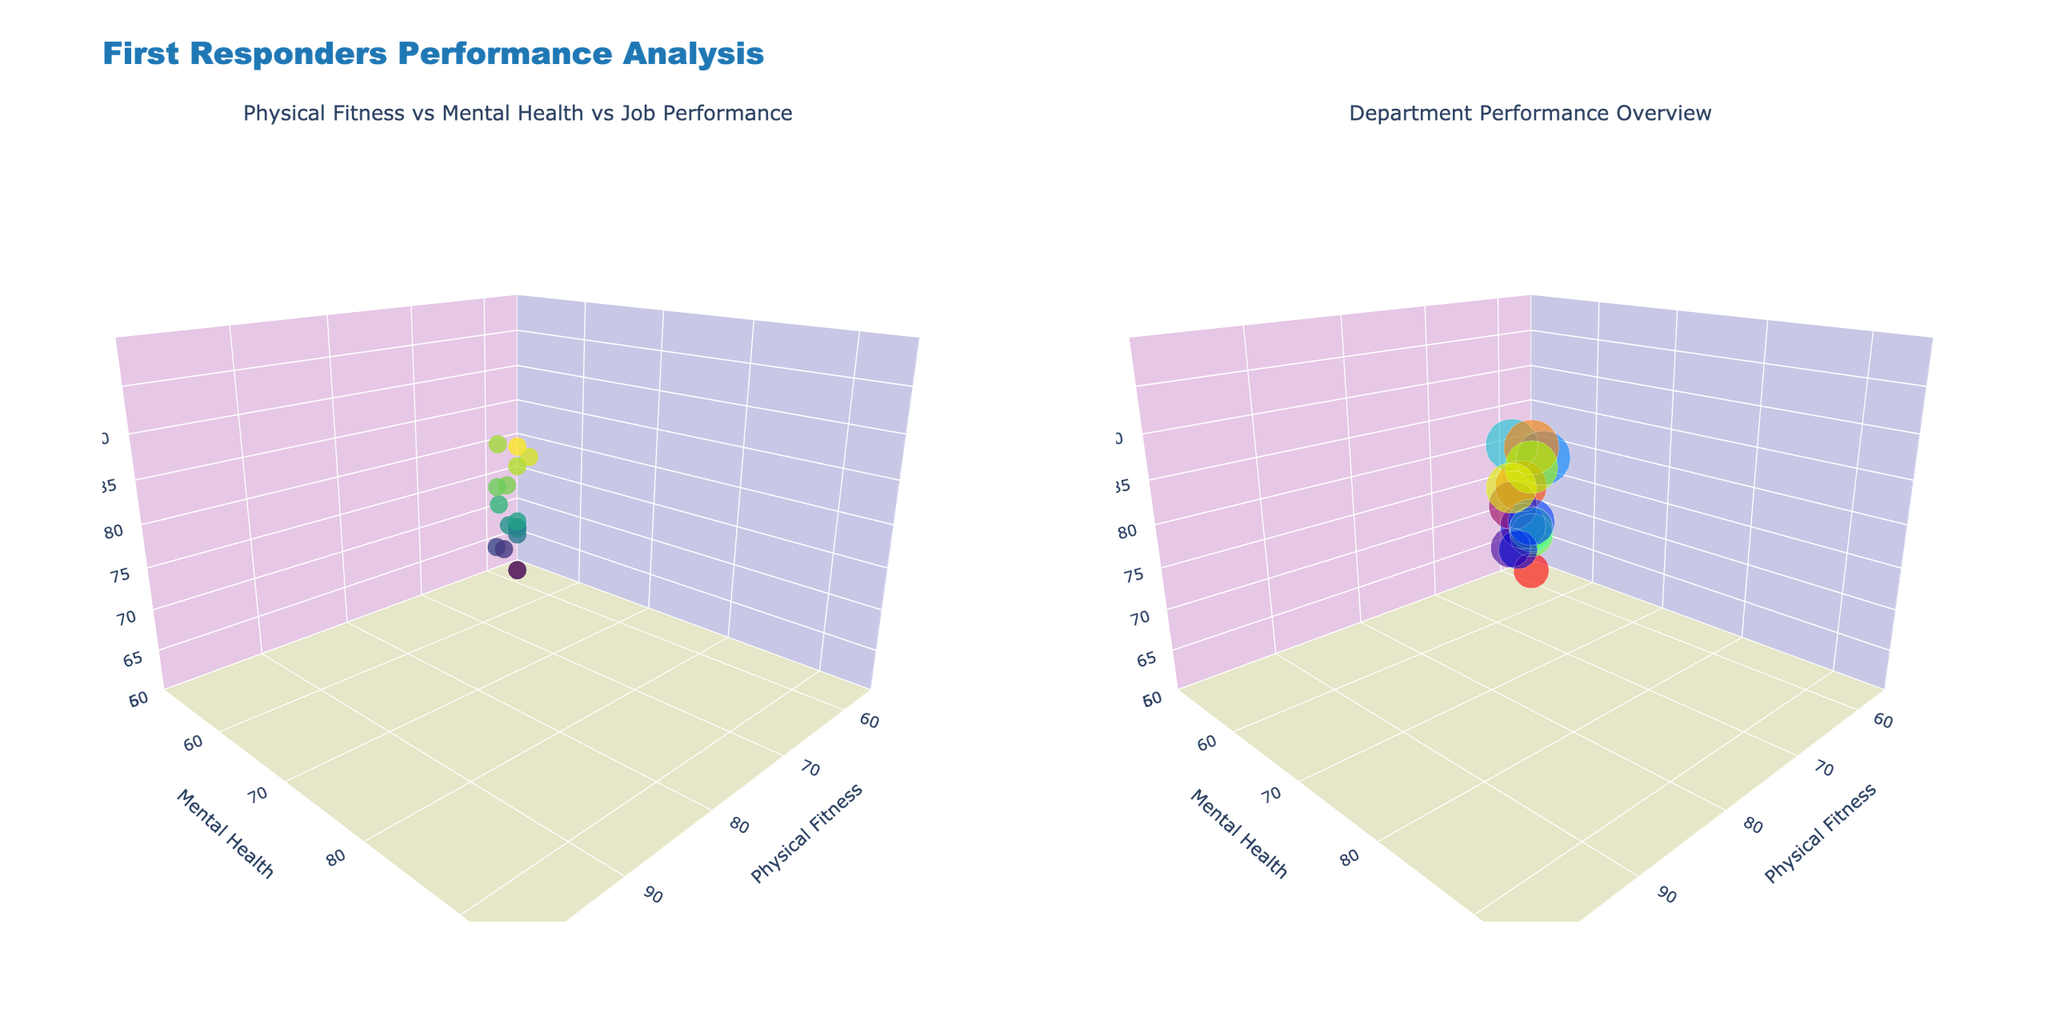what does the title of the figure say? The title of the figure displayed at the top of the plot provides an overall description of the data being visualized. It is "First Responders Performance Analysis".
Answer: First Responders Performance Analysis what are the axis titles for the scatter plot on the left? The axis titles for the scatter plot on the left describe what each axis represents. They are "Physical Fitness" for the x-axis, "Mental Health" for the y-axis, and "Job Performance" for the z-axis.
Answer: Physical Fitness, Mental Health, Job Performance how many data points appear in the scatter plot on the left? There is one marker for each data point in the scatter plot. Counting these markers gives the total number of data points, which is 15.
Answer: 15 which department has the highest job performance? To determine which department has the highest job performance, look for the data point that is highest along the z-axis. The SWAT Team in Boston has the highest job performance at 97.
Answer: SWAT Team which city is represented by the data point with the lowest physical fitness? To find the city with the data point having the lowest physical fitness, locate the point lowest on the x-axis. The Sheriff's Office in Houston has the lowest physical fitness at 60.
Answer: Houston is there a general trend between physical fitness, mental health, and job performance in the scatter plot on the left? Observing the scatter plot, the data points generally show that higher physical fitness and mental health correlate with higher job performance, indicating a positive relationship among these variables.
Answer: Positive correlation which department has the smallest marker in the bubble chart, indicating lower job performance? In the bubble chart, smaller markers indicate lower job performance values. The Sheriff's Office in Houston has the smallest marker, indicating a job performance of 62.
Answer: Sheriff's Office what is the average job performance across all departments? To find the average job performance, add up all the job performance values and divide by the number of data points: (92 + 75 + 95 + 62 + 80 + 90 + 76 + 97 + 70 + 85 + 78 + 93 + 68 + 82 + 89) / 15 = 83.4.
Answer: 83.4 compare the job performance of Emergency Medical Services in Los Angeles with the Coast Guard in Miami. Which is higher? To compare, check the z-values of both points. Emergency Medical Services in Los Angeles has a job performance of 95, while the Coast Guard in Miami has 80. The job performance of Emergency Medical Services is higher.
Answer: Emergency Medical Services what is the range of physical fitness values represented in both plots? The range is determined by the minimum and maximum values along the x-axis. The minimum physical fitness is 60, and the maximum is 95, giving a range of 35.
Answer: 35 